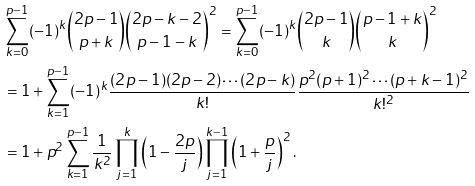<formula> <loc_0><loc_0><loc_500><loc_500>& \sum _ { k = 0 } ^ { p - 1 } ( - 1 ) ^ { k } \binom { 2 p - 1 } { p + k } \binom { 2 p - k - 2 } { p - 1 - k } ^ { 2 } = \sum _ { k = 0 } ^ { p - 1 } ( - 1 ) ^ { k } \binom { 2 p - 1 } { k } \binom { p - 1 + k } { k } ^ { 2 } \\ & = 1 + \sum _ { k = 1 } ^ { p - 1 } ( - 1 ) ^ { k } \frac { ( 2 p - 1 ) ( 2 p - 2 ) \cdots ( 2 p - k ) } { k ! } \frac { p ^ { 2 } ( p + 1 ) ^ { 2 } \cdots ( p + k - 1 ) ^ { 2 } } { k ! ^ { 2 } } \\ & = 1 + p ^ { 2 } \sum _ { k = 1 } ^ { p - 1 } \frac { 1 } { k ^ { 2 } } \prod _ { j = 1 } ^ { k } \left ( 1 - \frac { 2 p } { j } \right ) \prod _ { j = 1 } ^ { k - 1 } \left ( 1 + \frac { p } { j } \right ) ^ { 2 } .</formula> 